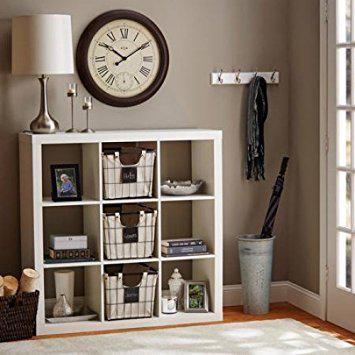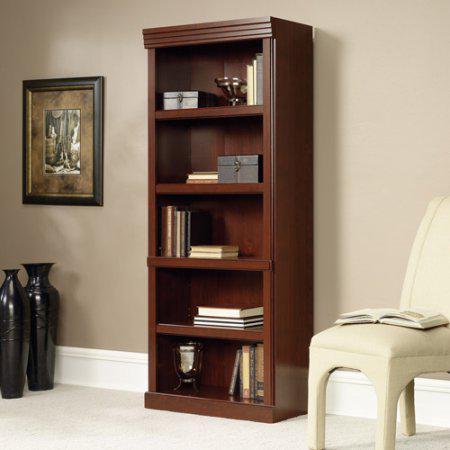The first image is the image on the left, the second image is the image on the right. Assess this claim about the two images: "An image of a brown bookshelf includes a ladder design of some type.". Correct or not? Answer yes or no. No. 